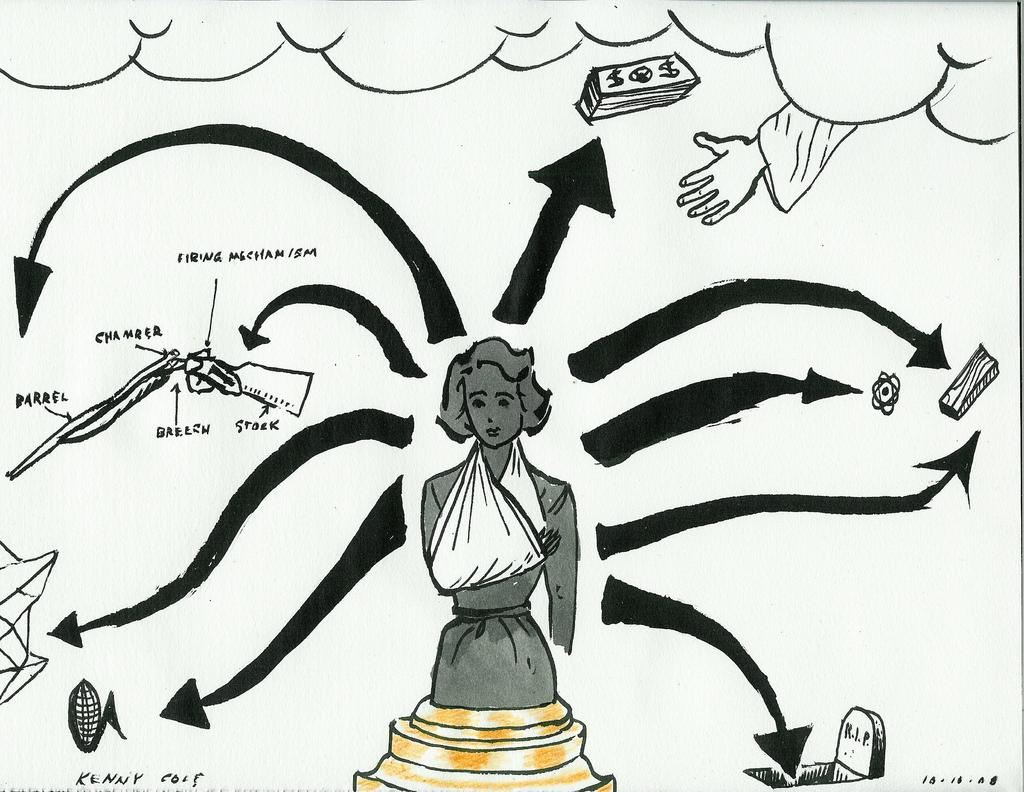What is the main subject of the image? The main subject of the image is a drawing of a lady. Are there any additional elements in the image besides the lady? Yes, there are arrows and writing in the image. Where is the kitten hiding in the image? There is no kitten present in the image. What type of shop is depicted in the image? The image does not depict a shop; it is a drawing of a lady with arrows and writing. 